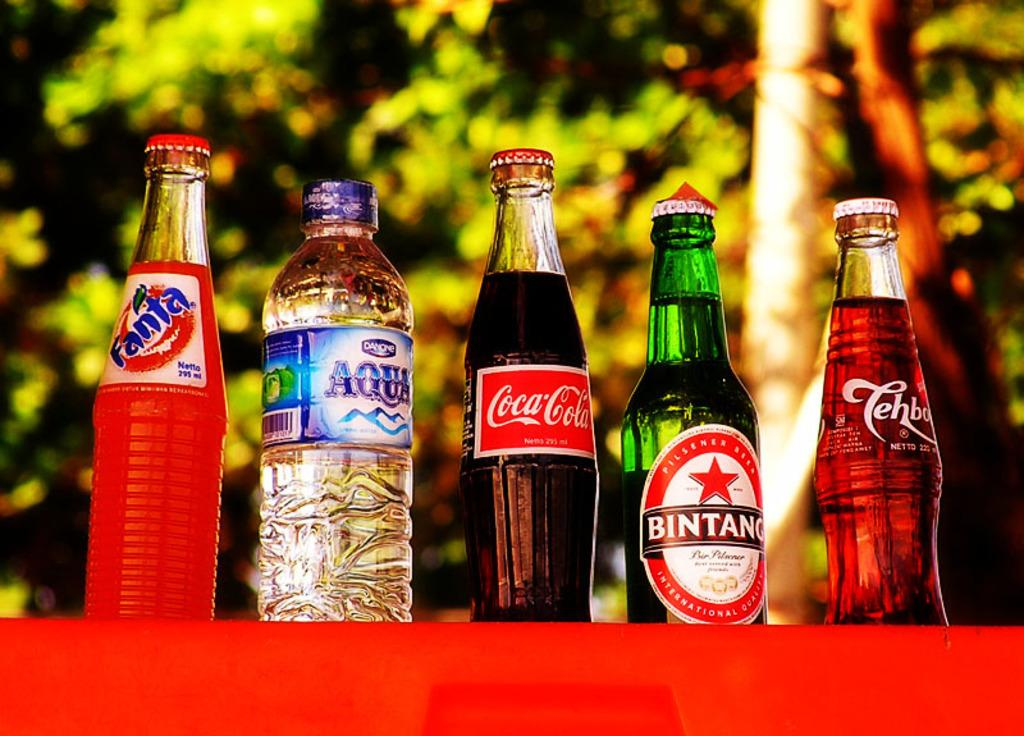How many different types of bottles are in the image? There are five different kinds of bottles in the image. What can be read on the labels of the bottles? The labels on the bottles include fanta, Aqua, Coca Cola, and some other names. What can be seen in the background of the image? There are trees visible behind the bottles. Can you describe the taste of the bottles in the image? The taste of the bottles cannot be determined from the image, as it only shows the appearance of the bottles and their labels. 